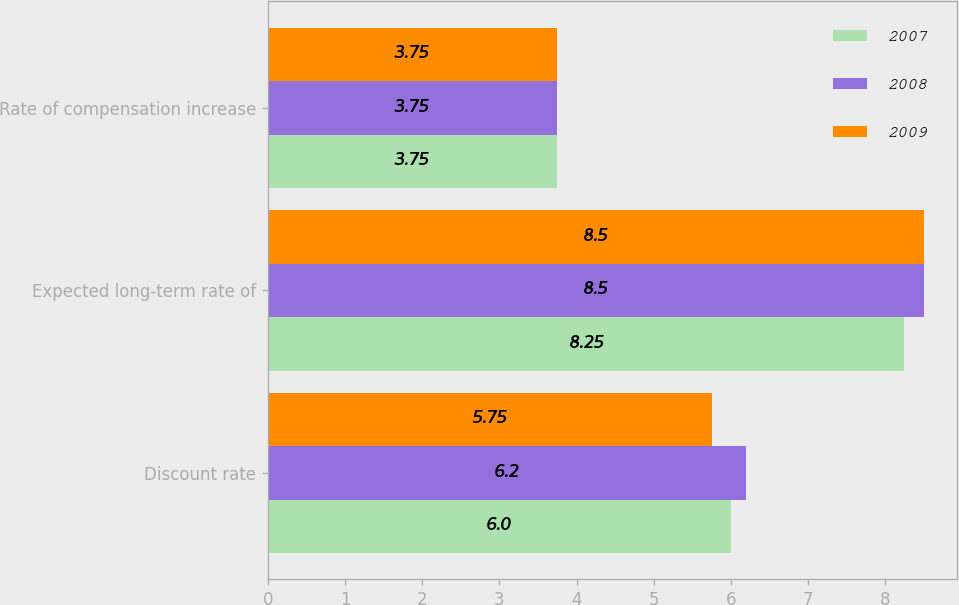<chart> <loc_0><loc_0><loc_500><loc_500><stacked_bar_chart><ecel><fcel>Discount rate<fcel>Expected long-term rate of<fcel>Rate of compensation increase<nl><fcel>2007<fcel>6<fcel>8.25<fcel>3.75<nl><fcel>2008<fcel>6.2<fcel>8.5<fcel>3.75<nl><fcel>2009<fcel>5.75<fcel>8.5<fcel>3.75<nl></chart> 